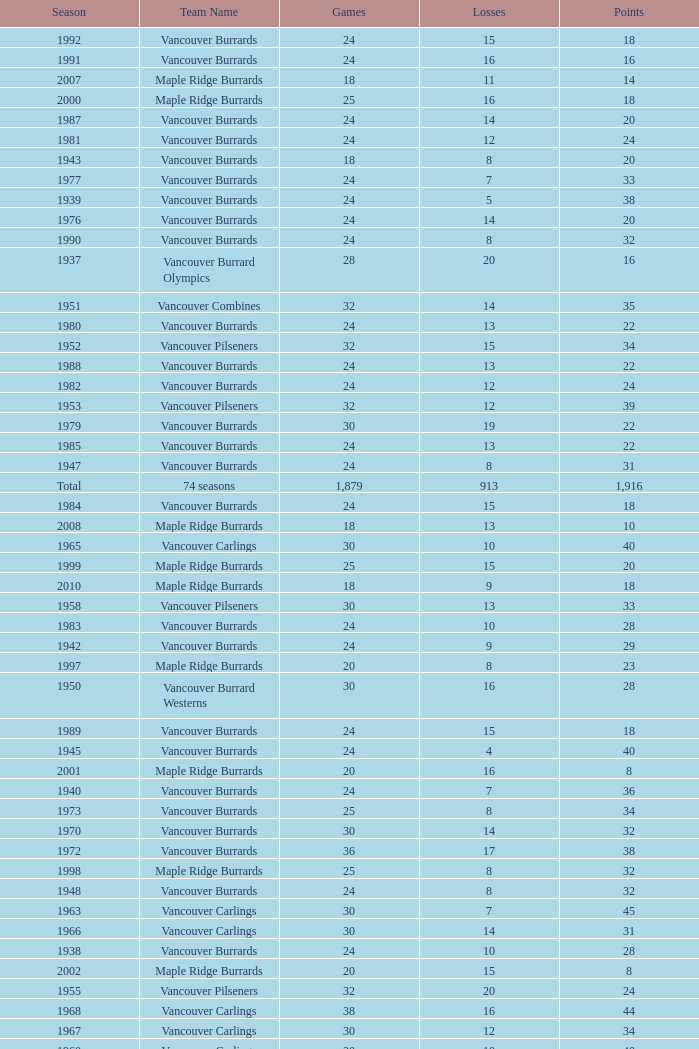What's the total number of games with more than 20 points for the 1976 season? 0.0. 